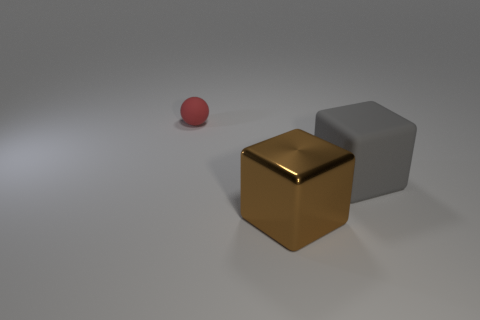Add 3 brown blocks. How many objects exist? 6 Subtract all balls. How many objects are left? 2 Subtract all tiny blue rubber spheres. Subtract all large brown metallic objects. How many objects are left? 2 Add 3 gray objects. How many gray objects are left? 4 Add 1 shiny cubes. How many shiny cubes exist? 2 Subtract 0 brown cylinders. How many objects are left? 3 